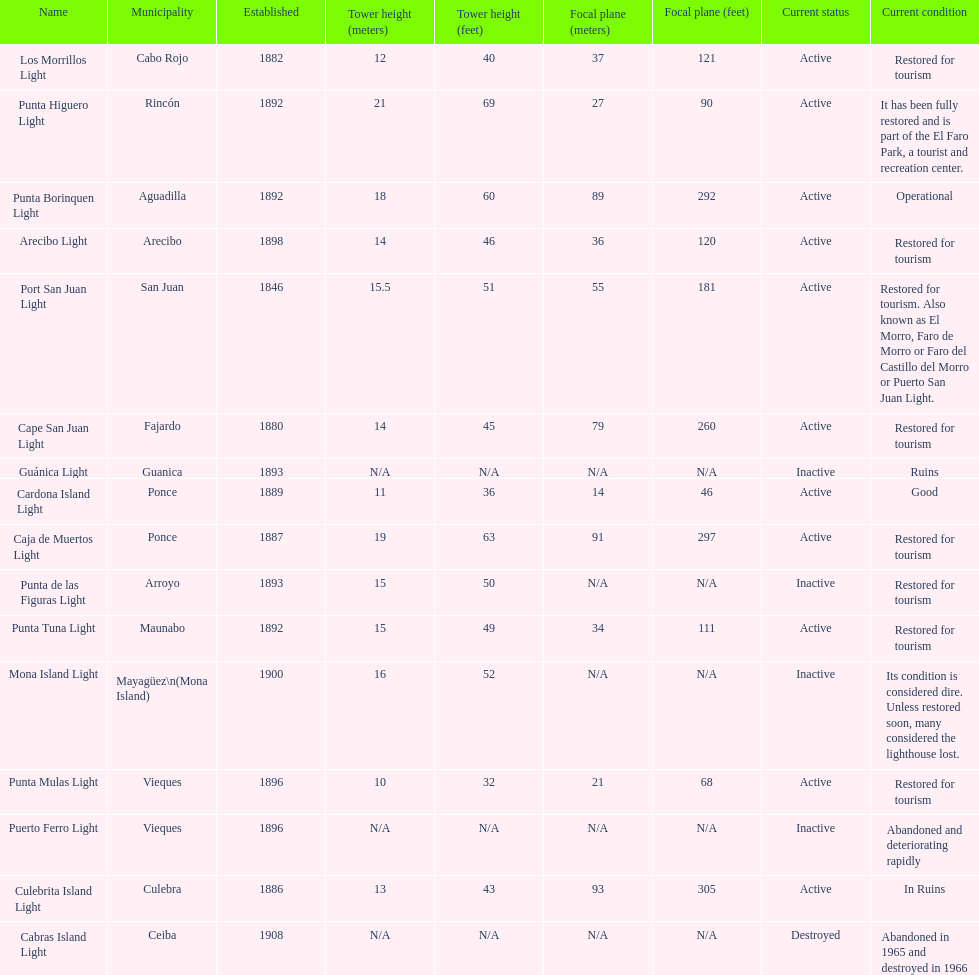Were any towers established before the year 1800? No. 